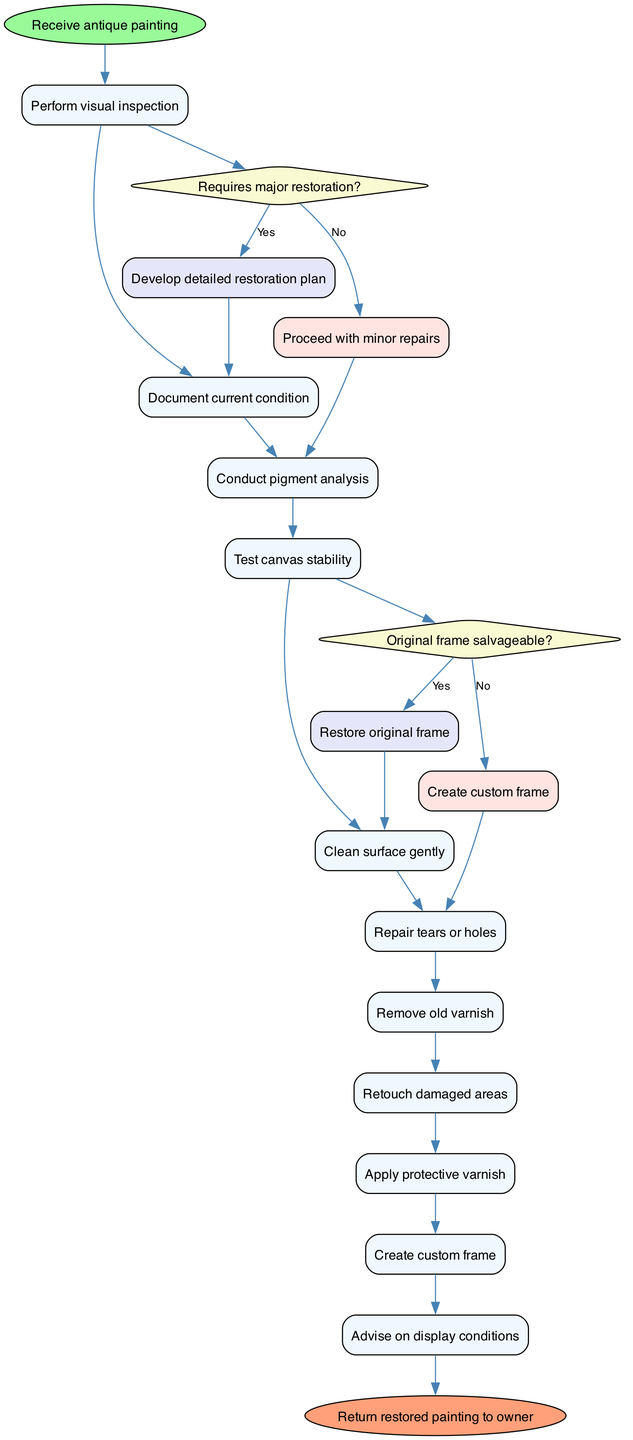What is the initial node in the diagram? The initial node is labeled "Receive antique painting", which represents the starting point of the restoration process.
Answer: Receive antique painting How many activities are listed in the diagram? There are ten activities listed in the diagram, each representing a step in the restoration of the antique painting.
Answer: 10 What decision is made after "Conduct pigment analysis"? After conducting pigment analysis, the next decision is whether major restoration is required, which determines the subsequent steps taken in the restoration process.
Answer: Requires major restoration? If the answer to "Requires major restoration?" is yes, what is the next step? If the answer is yes, the next step would be to "Develop detailed restoration plan," which outlines the necessary actions to restore the painting adequately.
Answer: Develop detailed restoration plan What activity follows "Retouch damaged areas"? The activity that follows "Retouch damaged areas" is "Apply protective varnish," which is crucial for preserving the newly retouched areas of the painting.
Answer: Apply protective varnish What happens if the original frame is not salvageable? If the original frame is not salvageable, the next action taken is to "Create custom frame," which means a new frame will be made to display the restored painting.
Answer: Create custom frame How does the diagram conclude after all activities? The diagram concludes with the final node, which is "Return restored painting to owner," indicating that the restoration process ends with the owner receiving the finished painting.
Answer: Return restored painting to owner Which step comes before "Clean surface gently"? The step before "Clean surface gently" is "Document current condition," which involves noting the existing state of the painting before any cleaning or restoration begins.
Answer: Document current condition What is the last activity before the final node in the diagram? The last activity before reaching the final node is "Apply protective varnish," which is the final step in the restoration process before handing the painting back to the owner.
Answer: Apply protective varnish 